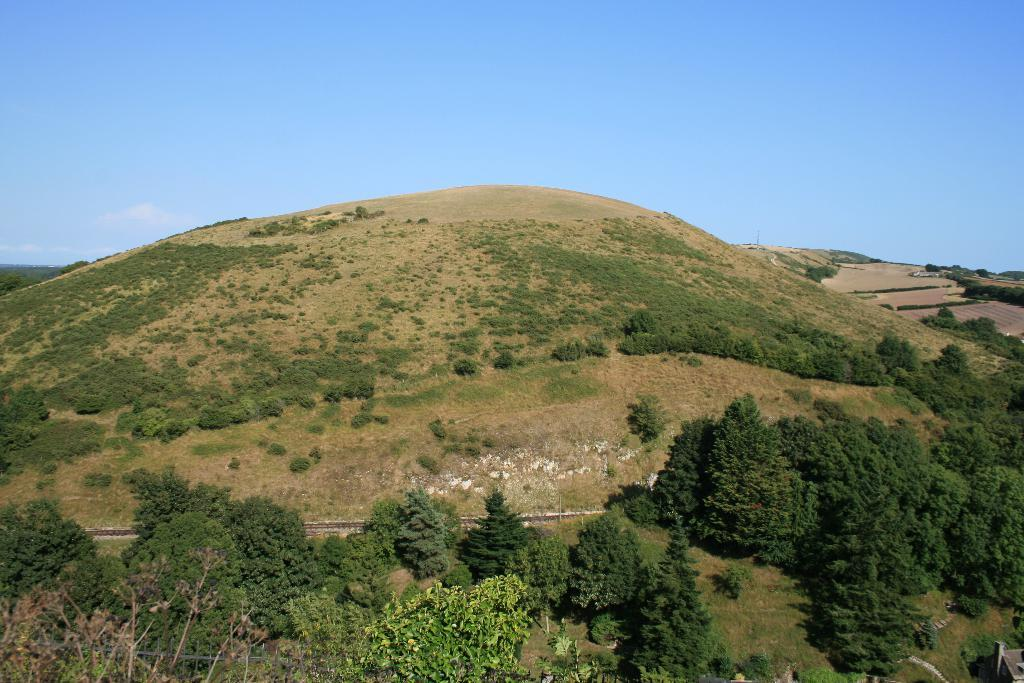What is the main feature in the center of the image? There is greenery in the center of the image. What type of support can be seen in the image? There is no support visible in the image; it only features greenery in the center. 